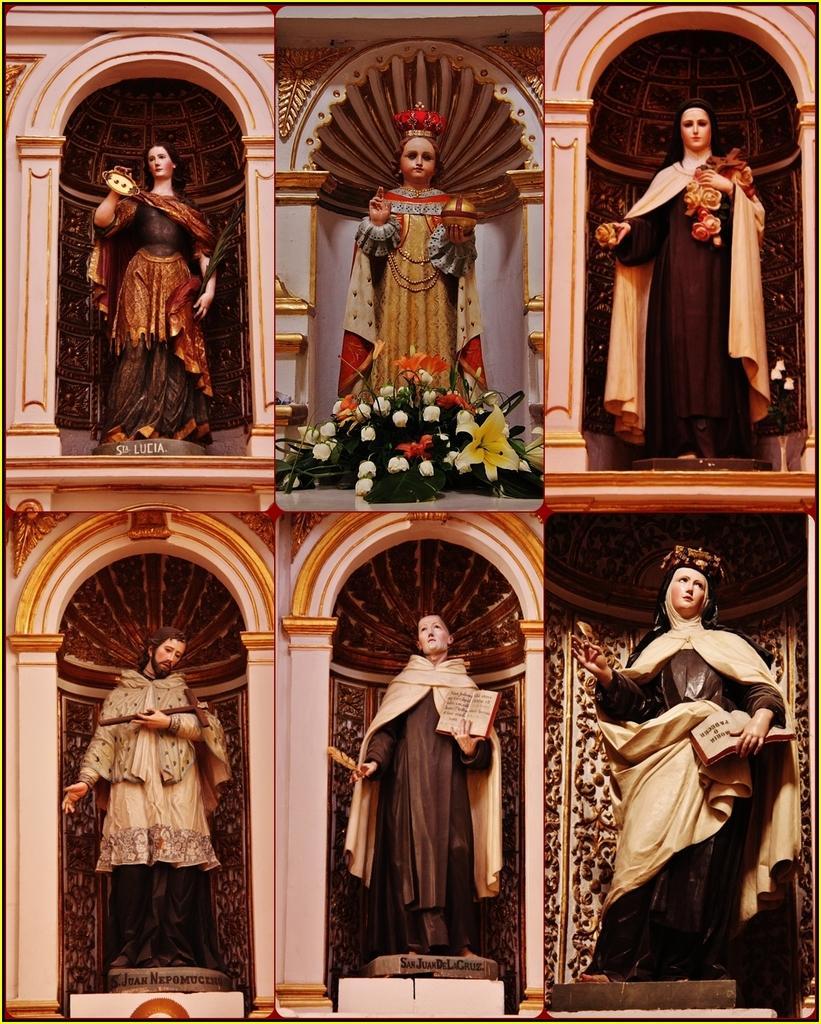Please provide a concise description of this image. This picture is a collage picture. In this image there are statues. On the left side of the image there is a statue of a woman standing and holding the object. In the middle of the image there are flowers. At the bottom there are two statues holding the books. There is a text at the bottom of the statues. 